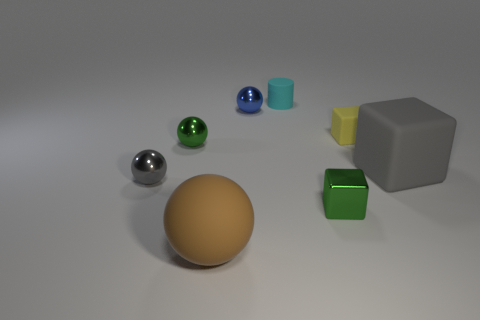Are there any shiny objects that have the same color as the big block?
Your answer should be compact. Yes. Does the rubber thing that is in front of the gray sphere have the same shape as the tiny cyan object?
Offer a very short reply. No. What size is the rubber object in front of the large object behind the gray ball?
Give a very brief answer. Large. The tiny thing that is the same material as the small cyan cylinder is what color?
Your answer should be compact. Yellow. How many gray matte blocks have the same size as the yellow matte object?
Offer a very short reply. 0. How many gray objects are either big matte blocks or large objects?
Your answer should be compact. 1. What number of objects are big yellow shiny blocks or big matte things on the right side of the small cyan thing?
Offer a terse response. 1. What is the material of the gray thing to the left of the large gray matte block?
Your answer should be compact. Metal. What is the shape of the blue metal object that is the same size as the gray metallic object?
Ensure brevity in your answer.  Sphere. Is there another large thing of the same shape as the yellow rubber object?
Give a very brief answer. Yes. 